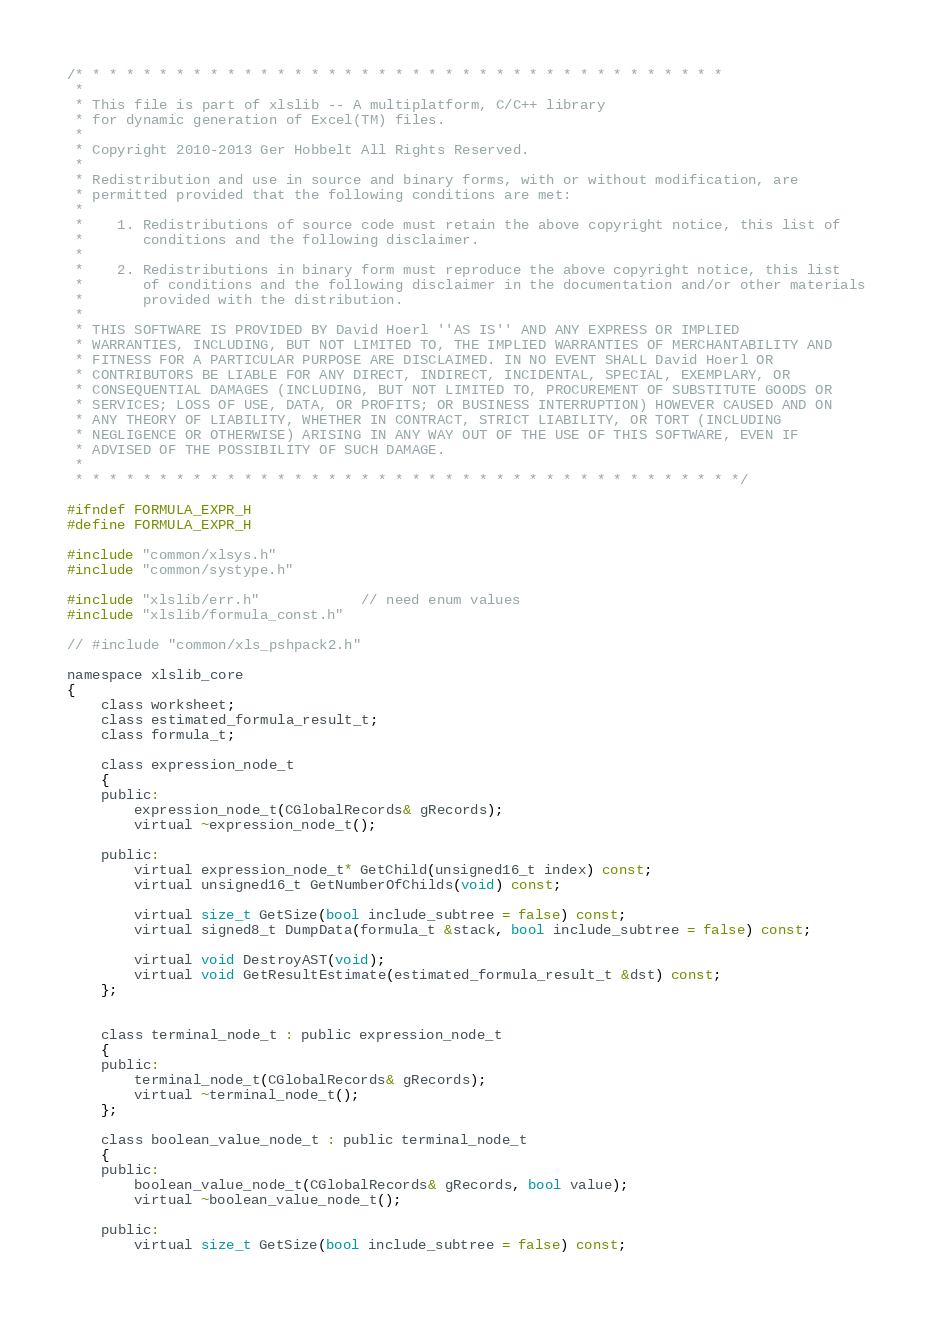<code> <loc_0><loc_0><loc_500><loc_500><_C_>/* * * * * * * * * * * * * * * * * * * * * * * * * * * * * * * * * * * * * * *
 *
 * This file is part of xlslib -- A multiplatform, C/C++ library
 * for dynamic generation of Excel(TM) files.
 *
 * Copyright 2010-2013 Ger Hobbelt All Rights Reserved.
 *
 * Redistribution and use in source and binary forms, with or without modification, are
 * permitted provided that the following conditions are met:
 *
 *    1. Redistributions of source code must retain the above copyright notice, this list of
 *       conditions and the following disclaimer.
 *
 *    2. Redistributions in binary form must reproduce the above copyright notice, this list
 *       of conditions and the following disclaimer in the documentation and/or other materials
 *       provided with the distribution.
 *
 * THIS SOFTWARE IS PROVIDED BY David Hoerl ''AS IS'' AND ANY EXPRESS OR IMPLIED
 * WARRANTIES, INCLUDING, BUT NOT LIMITED TO, THE IMPLIED WARRANTIES OF MERCHANTABILITY AND
 * FITNESS FOR A PARTICULAR PURPOSE ARE DISCLAIMED. IN NO EVENT SHALL David Hoerl OR
 * CONTRIBUTORS BE LIABLE FOR ANY DIRECT, INDIRECT, INCIDENTAL, SPECIAL, EXEMPLARY, OR
 * CONSEQUENTIAL DAMAGES (INCLUDING, BUT NOT LIMITED TO, PROCUREMENT OF SUBSTITUTE GOODS OR
 * SERVICES; LOSS OF USE, DATA, OR PROFITS; OR BUSINESS INTERRUPTION) HOWEVER CAUSED AND ON
 * ANY THEORY OF LIABILITY, WHETHER IN CONTRACT, STRICT LIABILITY, OR TORT (INCLUDING
 * NEGLIGENCE OR OTHERWISE) ARISING IN ANY WAY OUT OF THE USE OF THIS SOFTWARE, EVEN IF
 * ADVISED OF THE POSSIBILITY OF SUCH DAMAGE.
 *
 * * * * * * * * * * * * * * * * * * * * * * * * * * * * * * * * * * * * * * * */

#ifndef FORMULA_EXPR_H
#define FORMULA_EXPR_H

#include "common/xlsys.h"
#include "common/systype.h"

#include "xlslib/err.h"			// need enum values
#include "xlslib/formula_const.h"

// #include "common/xls_pshpack2.h"

namespace xlslib_core
{
	class worksheet;
    class estimated_formula_result_t;
    class formula_t;

	class expression_node_t
	{
	public:
		expression_node_t(CGlobalRecords& gRecords);
		virtual ~expression_node_t();

	public:
		virtual expression_node_t* GetChild(unsigned16_t index) const;
		virtual unsigned16_t GetNumberOfChilds(void) const;

		virtual size_t GetSize(bool include_subtree = false) const;
		virtual signed8_t DumpData(formula_t &stack, bool include_subtree = false) const;

		virtual void DestroyAST(void);
		virtual void GetResultEstimate(estimated_formula_result_t &dst) const;
	};


	class terminal_node_t : public expression_node_t
	{
	public:
		terminal_node_t(CGlobalRecords& gRecords);
		virtual ~terminal_node_t();
	};

	class boolean_value_node_t : public terminal_node_t
	{
	public:
		boolean_value_node_t(CGlobalRecords& gRecords, bool value);
		virtual ~boolean_value_node_t();

	public:
		virtual size_t GetSize(bool include_subtree = false) const;</code> 